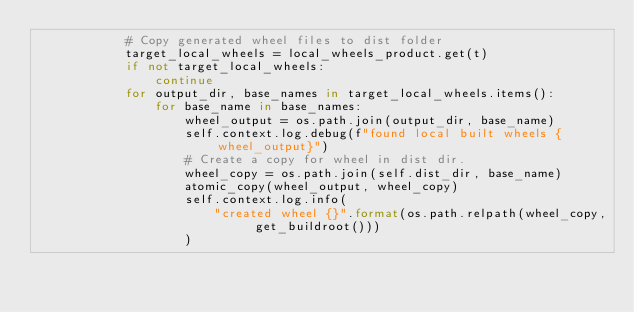Convert code to text. <code><loc_0><loc_0><loc_500><loc_500><_Python_>            # Copy generated wheel files to dist folder
            target_local_wheels = local_wheels_product.get(t)
            if not target_local_wheels:
                continue
            for output_dir, base_names in target_local_wheels.items():
                for base_name in base_names:
                    wheel_output = os.path.join(output_dir, base_name)
                    self.context.log.debug(f"found local built wheels {wheel_output}")
                    # Create a copy for wheel in dist dir.
                    wheel_copy = os.path.join(self.dist_dir, base_name)
                    atomic_copy(wheel_output, wheel_copy)
                    self.context.log.info(
                        "created wheel {}".format(os.path.relpath(wheel_copy, get_buildroot()))
                    )
</code> 